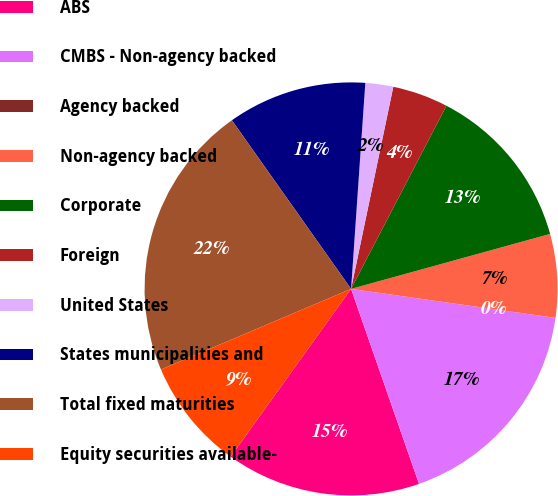<chart> <loc_0><loc_0><loc_500><loc_500><pie_chart><fcel>ABS<fcel>CMBS - Non-agency backed<fcel>Agency backed<fcel>Non-agency backed<fcel>Corporate<fcel>Foreign<fcel>United States<fcel>States municipalities and<fcel>Total fixed maturities<fcel>Equity securities available-<nl><fcel>15.24%<fcel>17.42%<fcel>0.0%<fcel>6.53%<fcel>13.07%<fcel>4.36%<fcel>2.18%<fcel>10.89%<fcel>21.59%<fcel>8.71%<nl></chart> 